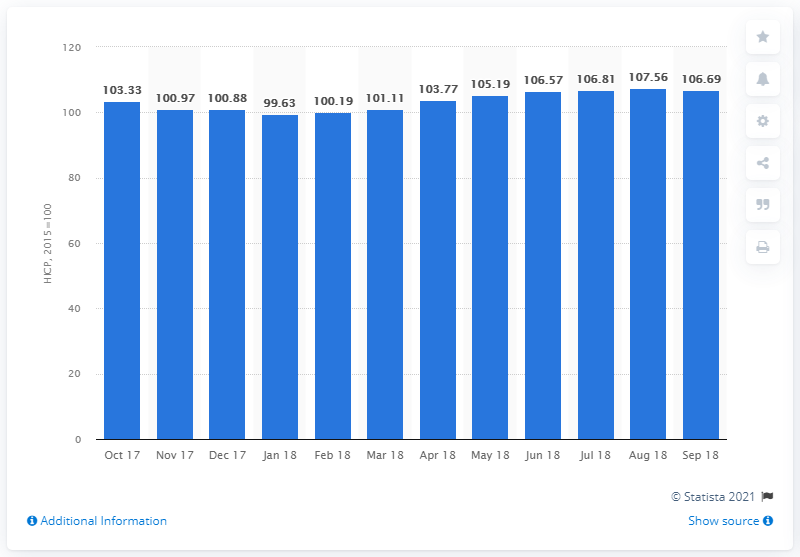List a handful of essential elements in this visual. In September 2018, the consumer price index for all items in Malta was 106.69. 